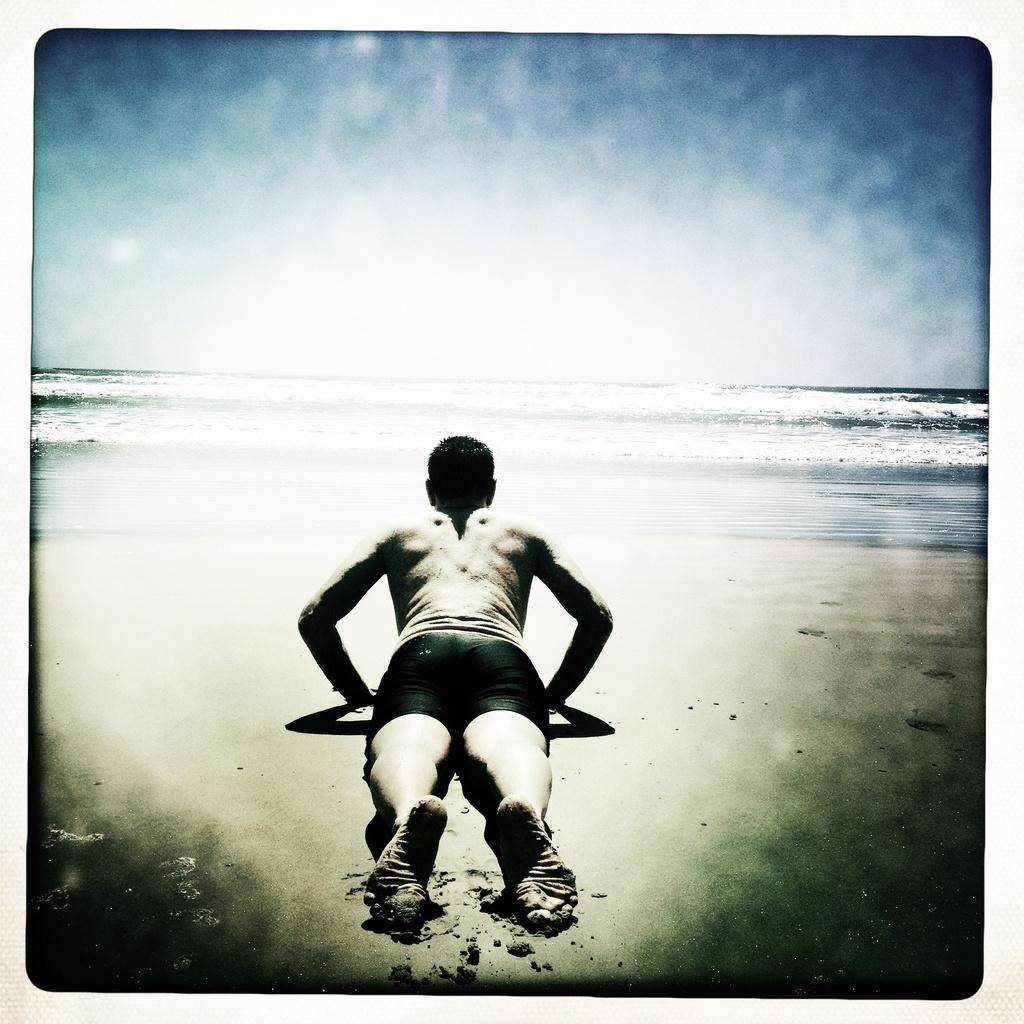Who or what is located in the front of the image? There is a person in the front of the image. What can be seen in the background of the image? Water and the sky are visible in the background of the image. How far away is the maid from the van in the image? There is no maid or van present in the image. 